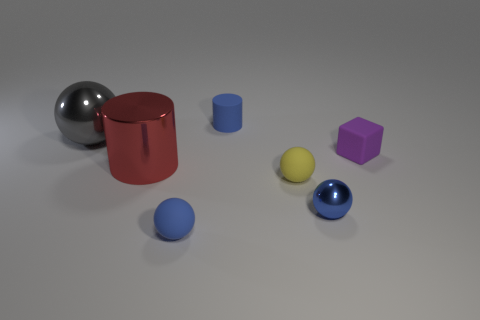There is a cylinder in front of the metal sphere that is behind the small block; what is its size?
Your response must be concise. Large. The red cylinder is what size?
Keep it short and to the point. Large. Does the large metal thing in front of the tiny purple thing have the same color as the metal thing that is behind the purple rubber cube?
Ensure brevity in your answer.  No. How many other objects are there of the same material as the red cylinder?
Ensure brevity in your answer.  2. Is there a large blue cylinder?
Ensure brevity in your answer.  No. Do the small ball that is on the right side of the yellow rubber ball and the blue cylinder have the same material?
Your response must be concise. No. There is a blue thing that is the same shape as the large red shiny object; what is it made of?
Provide a succinct answer. Rubber. What is the material of the small cylinder that is the same color as the tiny metal ball?
Give a very brief answer. Rubber. Are there fewer big green metal things than blue matte cylinders?
Offer a very short reply. Yes. Do the shiny ball that is right of the red object and the small cylinder have the same color?
Your answer should be very brief. Yes. 